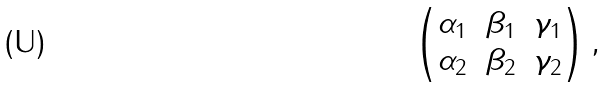<formula> <loc_0><loc_0><loc_500><loc_500>\begin{pmatrix} \alpha _ { 1 } & \beta _ { 1 } & \gamma _ { 1 } \\ \alpha _ { 2 } & \beta _ { 2 } & \gamma _ { 2 } \end{pmatrix} ,</formula> 